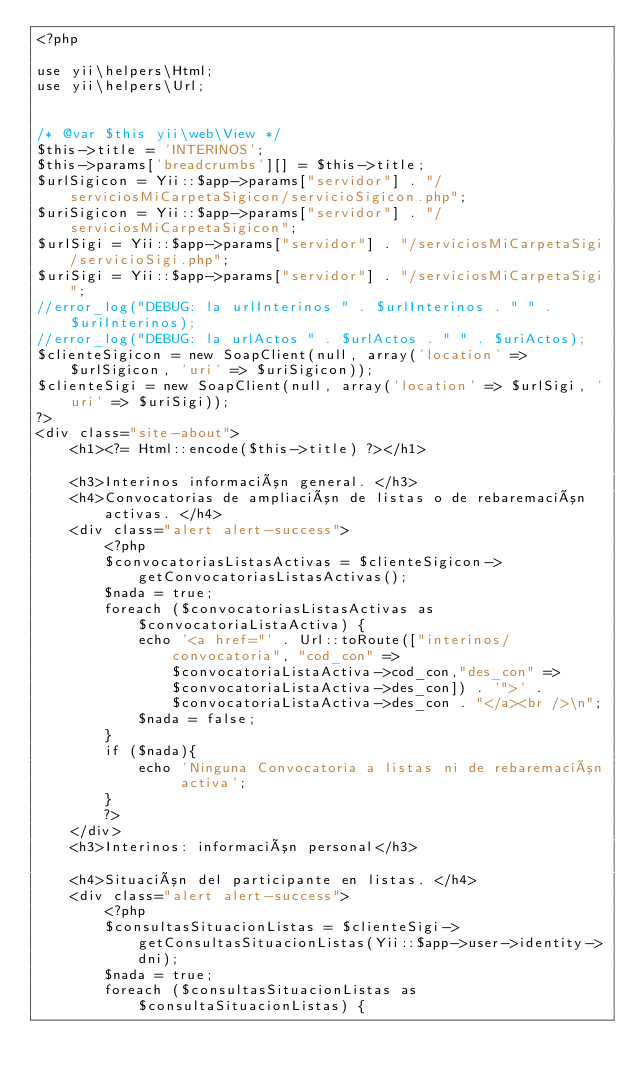Convert code to text. <code><loc_0><loc_0><loc_500><loc_500><_PHP_><?php

use yii\helpers\Html;
use yii\helpers\Url;


/* @var $this yii\web\View */
$this->title = 'INTERINOS';
$this->params['breadcrumbs'][] = $this->title;
$urlSigicon = Yii::$app->params["servidor"] . "/serviciosMiCarpetaSigicon/servicioSigicon.php";
$uriSigicon = Yii::$app->params["servidor"] . "/serviciosMiCarpetaSigicon";
$urlSigi = Yii::$app->params["servidor"] . "/serviciosMiCarpetaSigi/servicioSigi.php";
$uriSigi = Yii::$app->params["servidor"] . "/serviciosMiCarpetaSigi";
//error_log("DEBUG: la urlInterinos " . $urlInterinos . " " . $uriInterinos);
//error_log("DEBUG: la urlActos " . $urlActos . " " . $uriActos);
$clienteSigicon = new SoapClient(null, array('location' => $urlSigicon, 'uri' => $uriSigicon));
$clienteSigi = new SoapClient(null, array('location' => $urlSigi, 'uri' => $uriSigi));
?>
<div class="site-about">
    <h1><?= Html::encode($this->title) ?></h1>

    <h3>Interinos información general. </h3>
    <h4>Convocatorias de ampliación de listas o de rebaremación activas. </h4> 
    <div class="alert alert-success">
        <?php
        $convocatoriasListasActivas = $clienteSigicon->getConvocatoriasListasActivas();
        $nada = true;
        foreach ($convocatoriasListasActivas as $convocatoriaListaActiva) {
            echo '<a href="' . Url::toRoute(["interinos/convocatoria", "cod_con" => $convocatoriaListaActiva->cod_con,"des_con" => $convocatoriaListaActiva->des_con]) . '">' . $convocatoriaListaActiva->des_con . "</a><br />\n";
            $nada = false;
        }
        if ($nada){
            echo 'Ninguna Convocatoria a listas ni de rebaremación activa';
        }
        ?>
    </div>
    <h3>Interinos: información personal</h3>

    <h4>Situación del participante en listas. </h4> 
    <div class="alert alert-success">
        <?php
        $consultasSituacionListas = $clienteSigi->getConsultasSituacionListas(Yii::$app->user->identity->dni);
        $nada = true;
        foreach ($consultasSituacionListas as $consultaSituacionListas) {</code> 